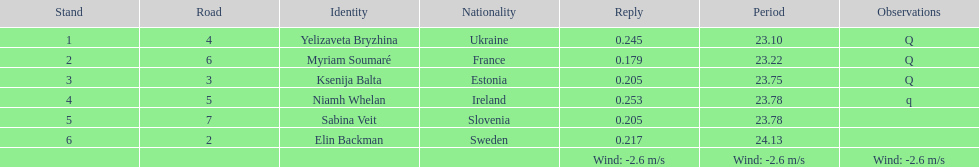Name of athlete who came in first in heat 1 of the women's 200 metres Yelizaveta Bryzhina. 